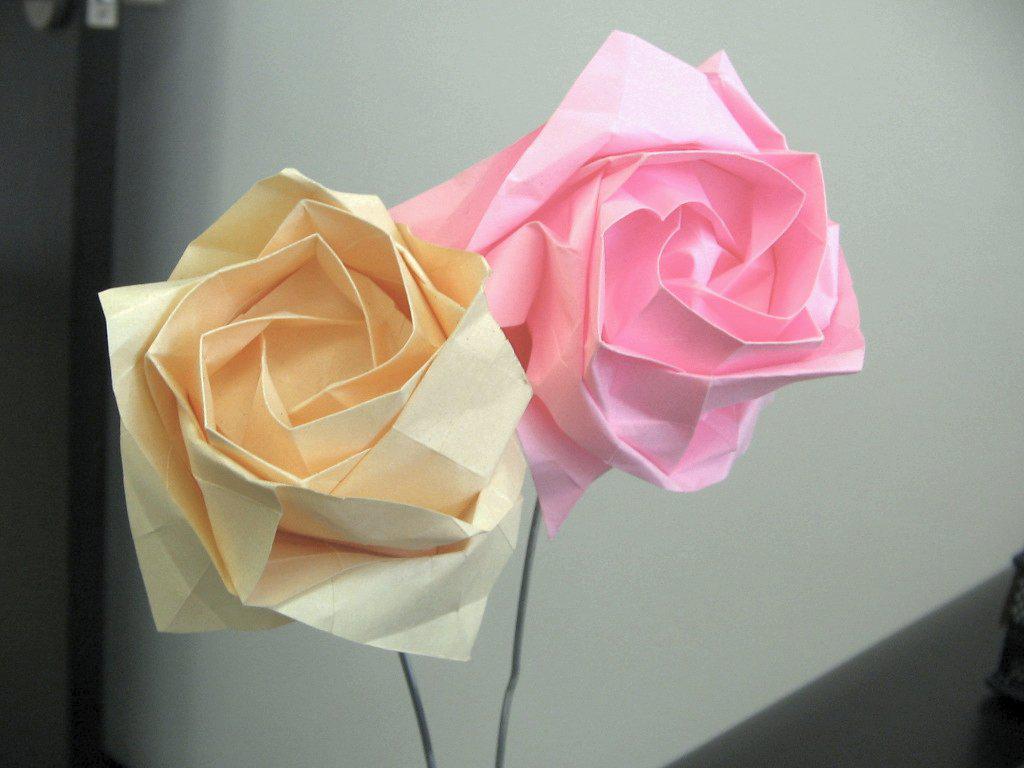Could you give a brief overview of what you see in this image? In this picture in the front of the there are flowers which are made up of papers. In the background there is a wall which is white in colour. 